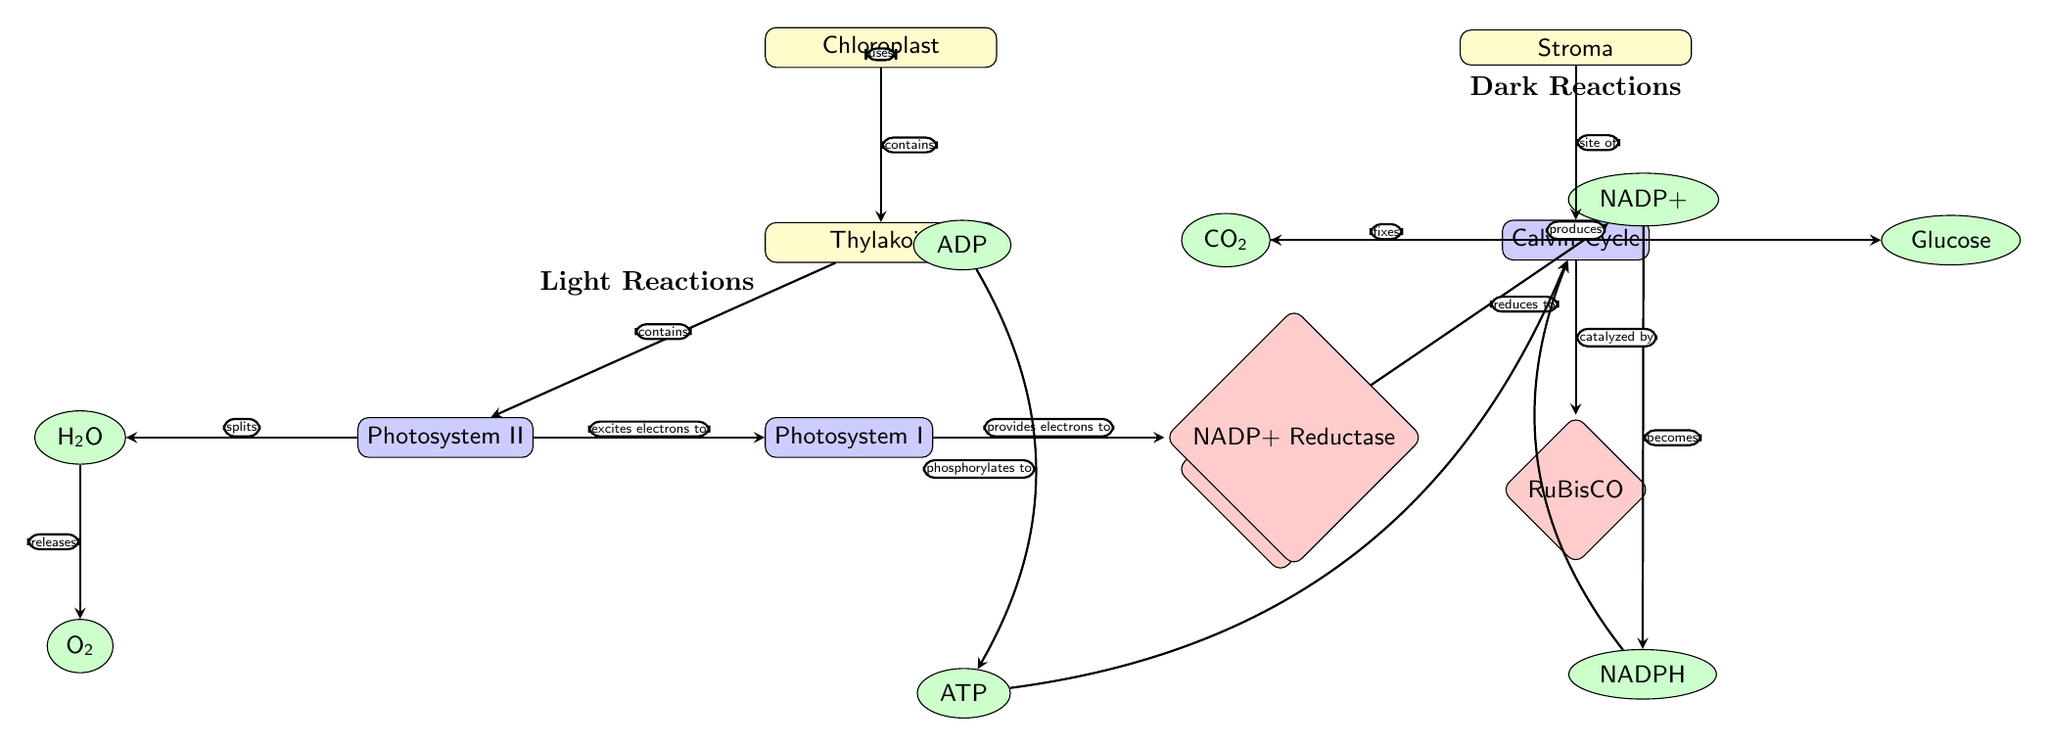What is the main site of the Calvin Cycle? The Calvin Cycle is located in the stroma, as indicated by the arrow leading from the stroma to the Calvin Cycle node in the diagram.
Answer: Stroma Which molecule is produced when water is split? The diagram shows an arrow leading from water, indicating it splits to release oxygen. Hence, the product from water splitting is oxygen.
Answer: Oxygen What two products are generated during the light reactions? The light reactions lead to the production of ATP and NADPH. These are the two molecules shown to be generated in the thylakoid area.
Answer: ATP and NADPH Which enzyme catalyzes the Calvin Cycle? According to the diagram, RuBisCO is listed as the enzyme that catalyzes the Calvin Cycle, reflecting its importance in this process.
Answer: RuBisCO What is the role of NADP+ in the light reactions? NADP+ receives electrons from Photosystem I through NADP+ reductase, reducing it to NADPH as shown by the arrows in the diagram.
Answer: Accepts electrons Which two molecules provide energy for the Calvin Cycle? The diagram indicates that ATP and NADPH, both produced in the light reactions, are used in the Calvin Cycle. Thus, they are the energy sources.
Answer: ATP and NADPH How many photosystems are involved in the light reactions? The diagram features two distinct processes labeled Photosystem II and Photosystem I, which are part of the light reactions. Therefore, there are two photosystems.
Answer: Two What gas is fixed during the Calvin Cycle? The diagram indicates that carbon dioxide is the molecule that is fixed as it enters the Calvin Cycle, which is a key part of this process.
Answer: Carbon dioxide What does ATP synthase do in the light reactions? ATP synthase phosphorylates ADP to produce ATP, as shown by the arrow indicating a conversion from ADP to ATP in the diagram.
Answer: Phosphorylates ADP 